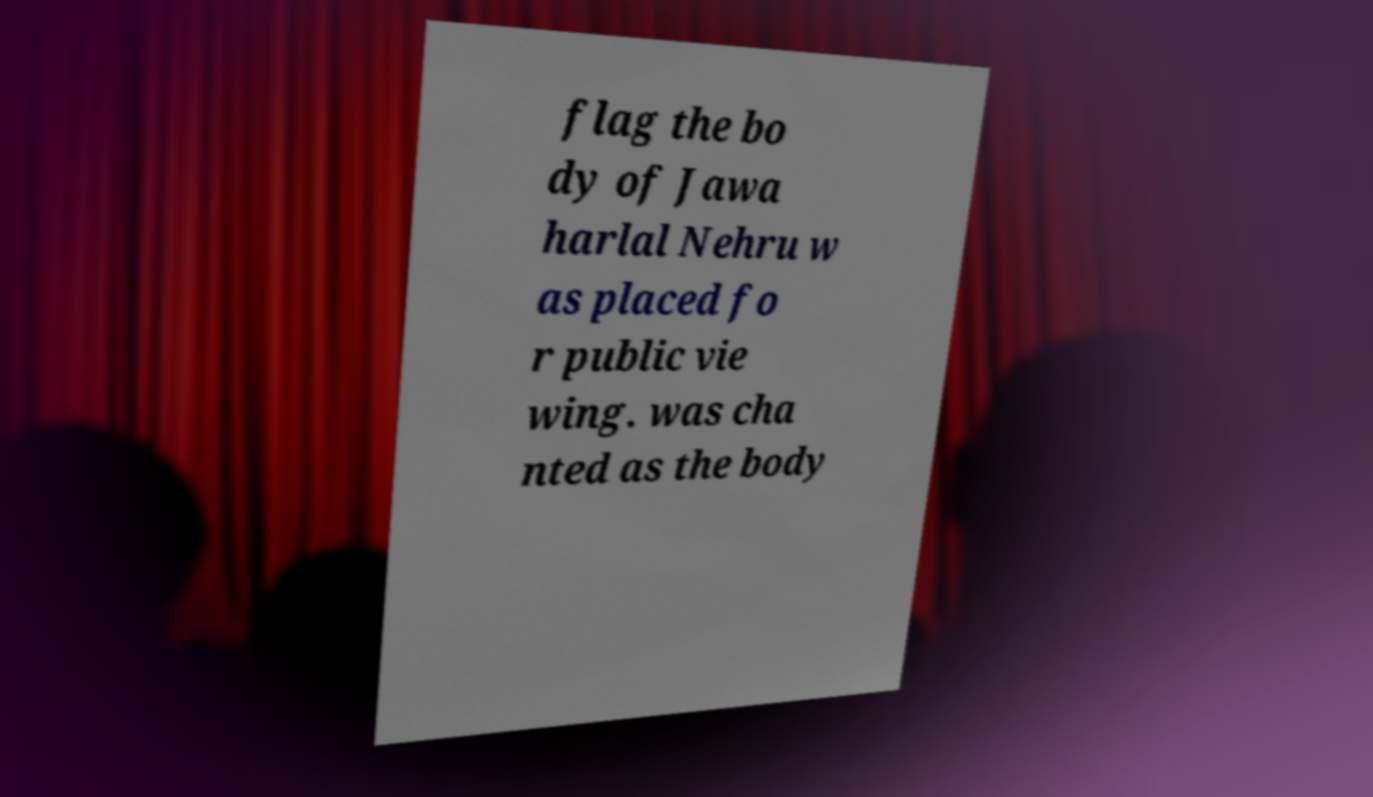Can you read and provide the text displayed in the image?This photo seems to have some interesting text. Can you extract and type it out for me? flag the bo dy of Jawa harlal Nehru w as placed fo r public vie wing. was cha nted as the body 